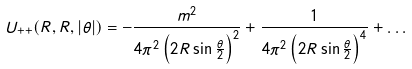Convert formula to latex. <formula><loc_0><loc_0><loc_500><loc_500>U _ { + + } ( R , R , | \theta | ) = - \frac { m ^ { 2 } } { 4 \pi ^ { 2 } \left ( 2 R \sin \frac { \theta } { 2 } \right ) ^ { 2 } } + \frac { 1 } { 4 \pi ^ { 2 } \left ( 2 R \sin \frac { \theta } { 2 } \right ) ^ { 4 } } + \dots</formula> 